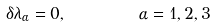Convert formula to latex. <formula><loc_0><loc_0><loc_500><loc_500>\delta \lambda _ { \alpha } = 0 , \text { \quad \ \ } \alpha = 1 , 2 , 3</formula> 